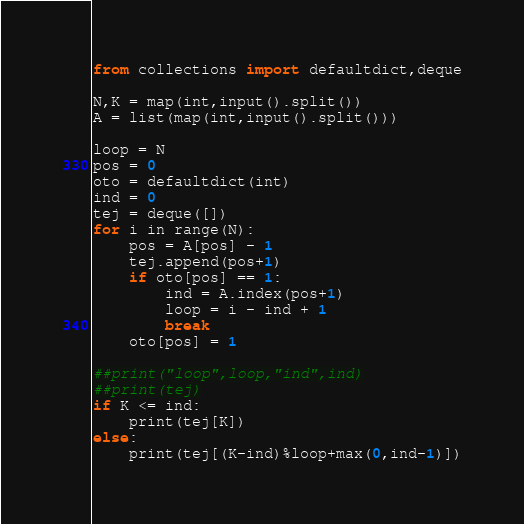Convert code to text. <code><loc_0><loc_0><loc_500><loc_500><_Python_>from collections import defaultdict,deque

N,K = map(int,input().split())
A = list(map(int,input().split()))

loop = N
pos = 0
oto = defaultdict(int)
ind = 0
tej = deque([])
for i in range(N):
    pos = A[pos] - 1
    tej.append(pos+1)
    if oto[pos] == 1:
        ind = A.index(pos+1)
        loop = i - ind + 1
        break
    oto[pos] = 1

##print("loop",loop,"ind",ind)
##print(tej)
if K <= ind:
    print(tej[K])
else:
    print(tej[(K-ind)%loop+max(0,ind-1)])</code> 